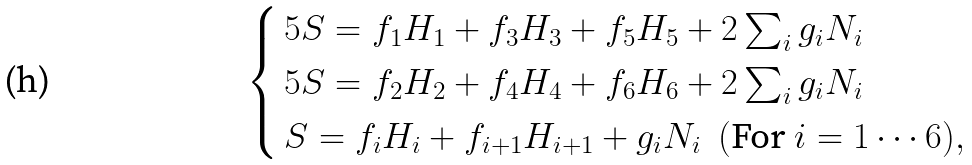Convert formula to latex. <formula><loc_0><loc_0><loc_500><loc_500>\begin{cases} \, 5 S = f _ { 1 } H _ { 1 } + f _ { 3 } H _ { 3 } + f _ { 5 } H _ { 5 } + 2 \sum _ { i } g _ { i } N _ { i } \\ \, 5 S = f _ { 2 } H _ { 2 } + f _ { 4 } H _ { 4 } + f _ { 6 } H _ { 6 } + 2 \sum _ { i } g _ { i } N _ { i } \\ \, S = f _ { i } H _ { i } + f _ { i + 1 } H _ { i + 1 } + g _ { i } N _ { i } \ \ ( \text {For} \ i = 1 \cdots 6 ) , \end{cases}</formula> 